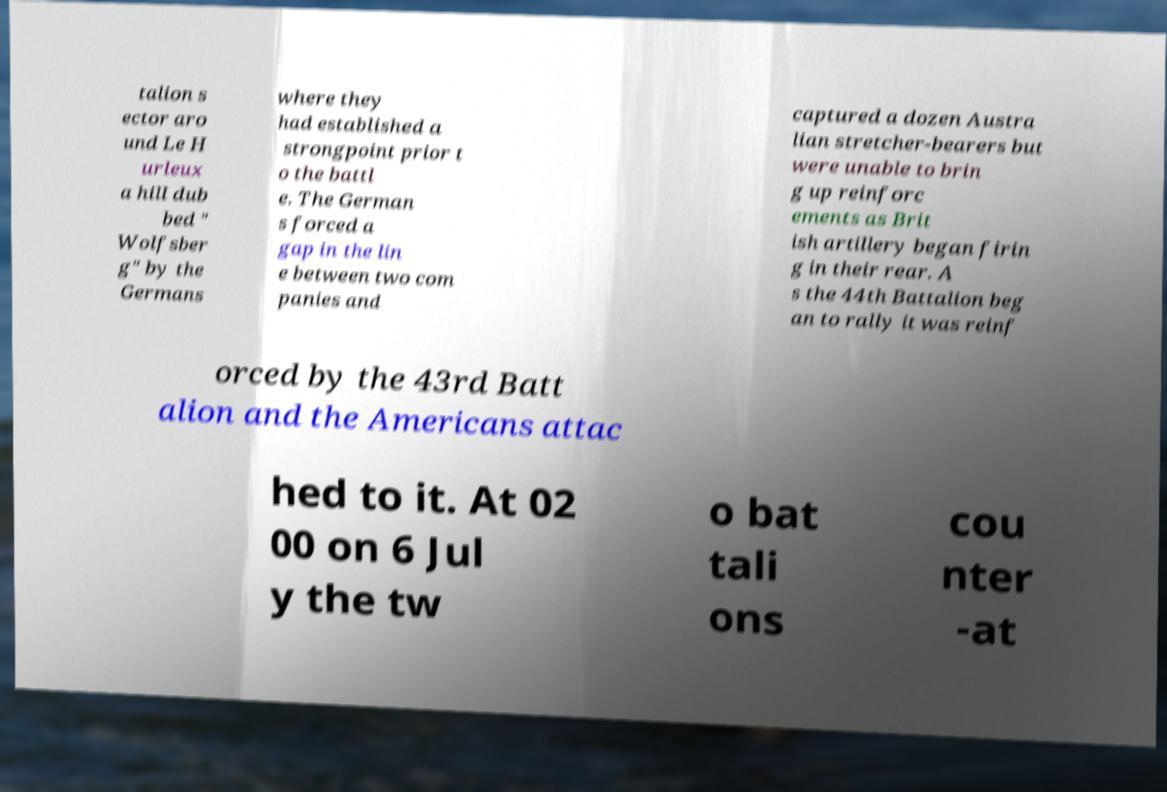Please read and relay the text visible in this image. What does it say? talion s ector aro und Le H urleux a hill dub bed " Wolfsber g" by the Germans where they had established a strongpoint prior t o the battl e. The German s forced a gap in the lin e between two com panies and captured a dozen Austra lian stretcher-bearers but were unable to brin g up reinforc ements as Brit ish artillery began firin g in their rear. A s the 44th Battalion beg an to rally it was reinf orced by the 43rd Batt alion and the Americans attac hed to it. At 02 00 on 6 Jul y the tw o bat tali ons cou nter -at 